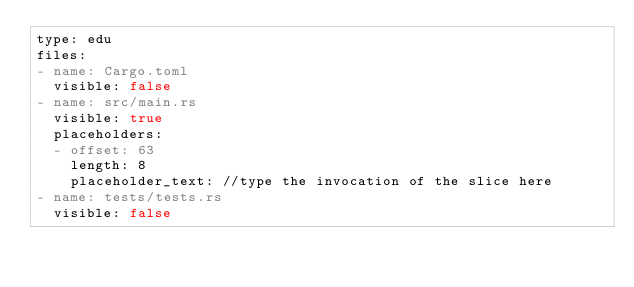Convert code to text. <code><loc_0><loc_0><loc_500><loc_500><_YAML_>type: edu
files:
- name: Cargo.toml
  visible: false
- name: src/main.rs
  visible: true
  placeholders:
  - offset: 63
    length: 8
    placeholder_text: //type the invocation of the slice here
- name: tests/tests.rs
  visible: false
</code> 